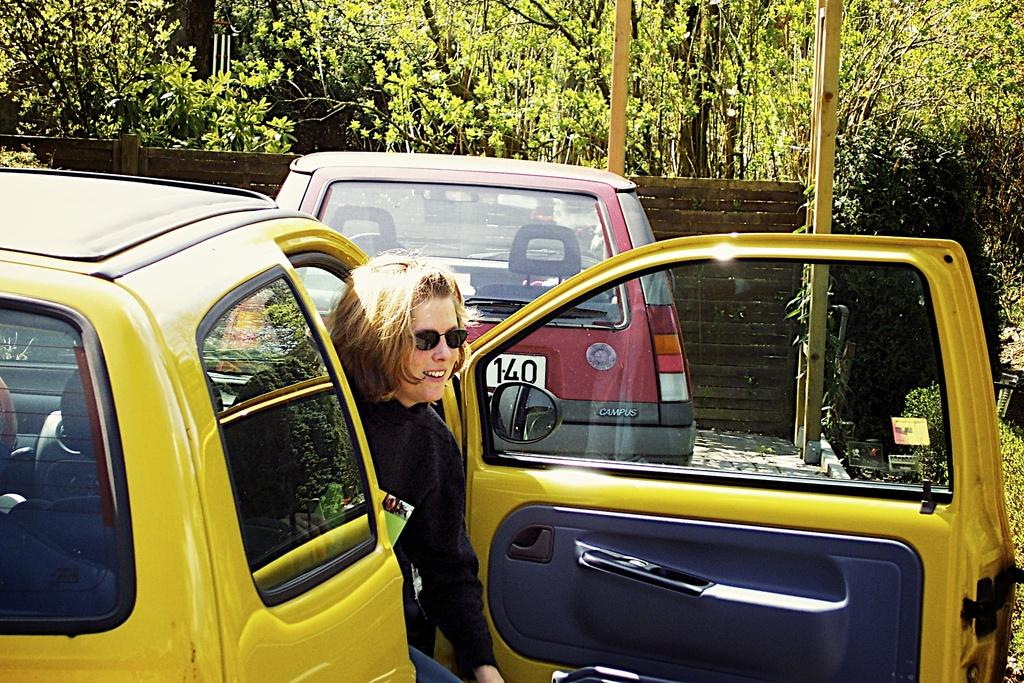<image>
Render a clear and concise summary of the photo. a lady getting out of a car with 140 on another car 